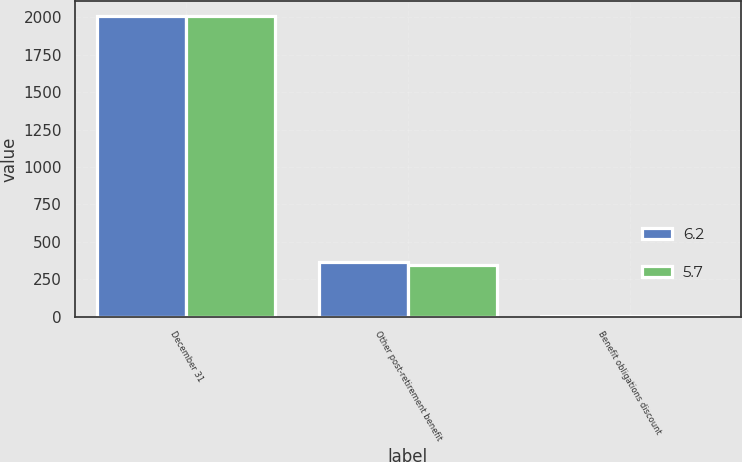Convert chart to OTSL. <chart><loc_0><loc_0><loc_500><loc_500><stacked_bar_chart><ecel><fcel>December 31<fcel>Other post-retirement benefit<fcel>Benefit obligations discount<nl><fcel>6.2<fcel>2007<fcel>362.9<fcel>6.2<nl><fcel>5.7<fcel>2006<fcel>345.1<fcel>5.7<nl></chart> 